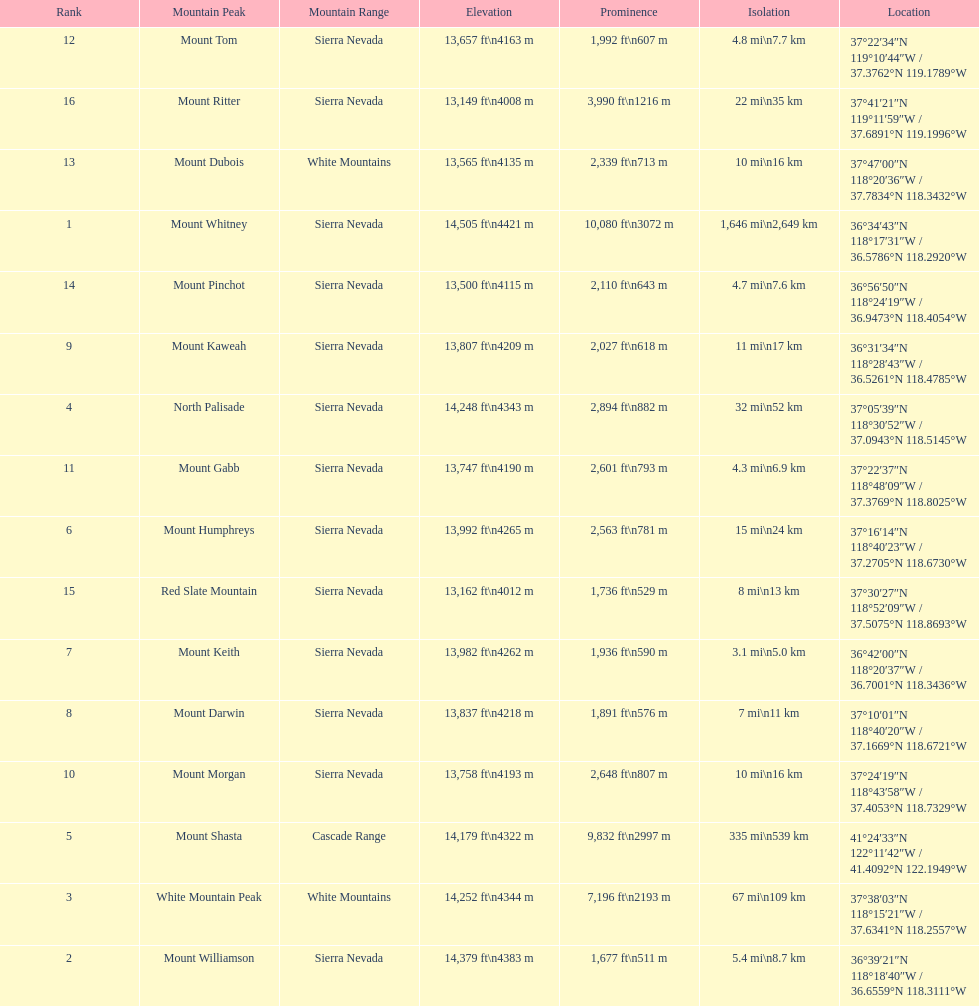Which mountain peak has a prominence more than 10,000 ft? Mount Whitney. Help me parse the entirety of this table. {'header': ['Rank', 'Mountain Peak', 'Mountain Range', 'Elevation', 'Prominence', 'Isolation', 'Location'], 'rows': [['12', 'Mount Tom', 'Sierra Nevada', '13,657\xa0ft\\n4163\xa0m', '1,992\xa0ft\\n607\xa0m', '4.8\xa0mi\\n7.7\xa0km', '37°22′34″N 119°10′44″W\ufeff / \ufeff37.3762°N 119.1789°W'], ['16', 'Mount Ritter', 'Sierra Nevada', '13,149\xa0ft\\n4008\xa0m', '3,990\xa0ft\\n1216\xa0m', '22\xa0mi\\n35\xa0km', '37°41′21″N 119°11′59″W\ufeff / \ufeff37.6891°N 119.1996°W'], ['13', 'Mount Dubois', 'White Mountains', '13,565\xa0ft\\n4135\xa0m', '2,339\xa0ft\\n713\xa0m', '10\xa0mi\\n16\xa0km', '37°47′00″N 118°20′36″W\ufeff / \ufeff37.7834°N 118.3432°W'], ['1', 'Mount Whitney', 'Sierra Nevada', '14,505\xa0ft\\n4421\xa0m', '10,080\xa0ft\\n3072\xa0m', '1,646\xa0mi\\n2,649\xa0km', '36°34′43″N 118°17′31″W\ufeff / \ufeff36.5786°N 118.2920°W'], ['14', 'Mount Pinchot', 'Sierra Nevada', '13,500\xa0ft\\n4115\xa0m', '2,110\xa0ft\\n643\xa0m', '4.7\xa0mi\\n7.6\xa0km', '36°56′50″N 118°24′19″W\ufeff / \ufeff36.9473°N 118.4054°W'], ['9', 'Mount Kaweah', 'Sierra Nevada', '13,807\xa0ft\\n4209\xa0m', '2,027\xa0ft\\n618\xa0m', '11\xa0mi\\n17\xa0km', '36°31′34″N 118°28′43″W\ufeff / \ufeff36.5261°N 118.4785°W'], ['4', 'North Palisade', 'Sierra Nevada', '14,248\xa0ft\\n4343\xa0m', '2,894\xa0ft\\n882\xa0m', '32\xa0mi\\n52\xa0km', '37°05′39″N 118°30′52″W\ufeff / \ufeff37.0943°N 118.5145°W'], ['11', 'Mount Gabb', 'Sierra Nevada', '13,747\xa0ft\\n4190\xa0m', '2,601\xa0ft\\n793\xa0m', '4.3\xa0mi\\n6.9\xa0km', '37°22′37″N 118°48′09″W\ufeff / \ufeff37.3769°N 118.8025°W'], ['6', 'Mount Humphreys', 'Sierra Nevada', '13,992\xa0ft\\n4265\xa0m', '2,563\xa0ft\\n781\xa0m', '15\xa0mi\\n24\xa0km', '37°16′14″N 118°40′23″W\ufeff / \ufeff37.2705°N 118.6730°W'], ['15', 'Red Slate Mountain', 'Sierra Nevada', '13,162\xa0ft\\n4012\xa0m', '1,736\xa0ft\\n529\xa0m', '8\xa0mi\\n13\xa0km', '37°30′27″N 118°52′09″W\ufeff / \ufeff37.5075°N 118.8693°W'], ['7', 'Mount Keith', 'Sierra Nevada', '13,982\xa0ft\\n4262\xa0m', '1,936\xa0ft\\n590\xa0m', '3.1\xa0mi\\n5.0\xa0km', '36°42′00″N 118°20′37″W\ufeff / \ufeff36.7001°N 118.3436°W'], ['8', 'Mount Darwin', 'Sierra Nevada', '13,837\xa0ft\\n4218\xa0m', '1,891\xa0ft\\n576\xa0m', '7\xa0mi\\n11\xa0km', '37°10′01″N 118°40′20″W\ufeff / \ufeff37.1669°N 118.6721°W'], ['10', 'Mount Morgan', 'Sierra Nevada', '13,758\xa0ft\\n4193\xa0m', '2,648\xa0ft\\n807\xa0m', '10\xa0mi\\n16\xa0km', '37°24′19″N 118°43′58″W\ufeff / \ufeff37.4053°N 118.7329°W'], ['5', 'Mount Shasta', 'Cascade Range', '14,179\xa0ft\\n4322\xa0m', '9,832\xa0ft\\n2997\xa0m', '335\xa0mi\\n539\xa0km', '41°24′33″N 122°11′42″W\ufeff / \ufeff41.4092°N 122.1949°W'], ['3', 'White Mountain Peak', 'White Mountains', '14,252\xa0ft\\n4344\xa0m', '7,196\xa0ft\\n2193\xa0m', '67\xa0mi\\n109\xa0km', '37°38′03″N 118°15′21″W\ufeff / \ufeff37.6341°N 118.2557°W'], ['2', 'Mount Williamson', 'Sierra Nevada', '14,379\xa0ft\\n4383\xa0m', '1,677\xa0ft\\n511\xa0m', '5.4\xa0mi\\n8.7\xa0km', '36°39′21″N 118°18′40″W\ufeff / \ufeff36.6559°N 118.3111°W']]} 